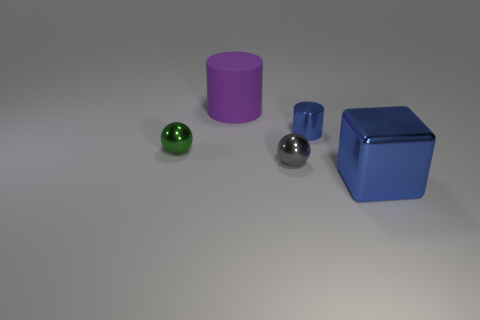There is a large thing that is to the right of the big purple cylinder; does it have the same color as the tiny shiny cylinder?
Your answer should be compact. Yes. How big is the object that is both behind the green ball and left of the small blue object?
Your answer should be compact. Large. What number of big things are either metallic cubes or gray metal spheres?
Provide a succinct answer. 1. There is a blue metallic thing in front of the tiny green metal ball; what is its shape?
Your response must be concise. Cube. What number of red shiny cylinders are there?
Keep it short and to the point. 0. Is the material of the tiny gray object the same as the small green sphere?
Give a very brief answer. Yes. Are there more rubber objects that are in front of the big rubber cylinder than big red metallic blocks?
Provide a succinct answer. No. What number of objects are either large yellow rubber cylinders or things that are to the right of the small green metal ball?
Give a very brief answer. 4. Are there more green metallic things behind the large blue metal block than gray things that are on the left side of the purple cylinder?
Make the answer very short. Yes. What is the big object in front of the cylinder that is behind the blue object that is behind the green metallic thing made of?
Your answer should be very brief. Metal. 